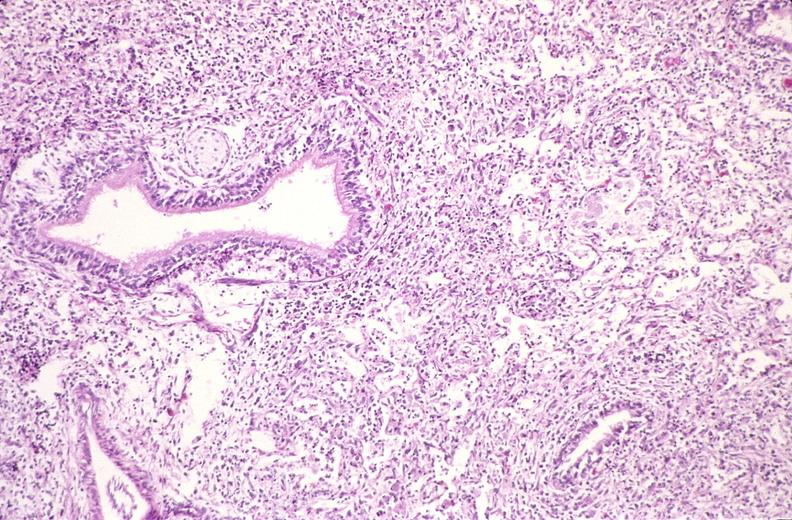does meningioma show lung, histoplasma pneumonia?
Answer the question using a single word or phrase. No 